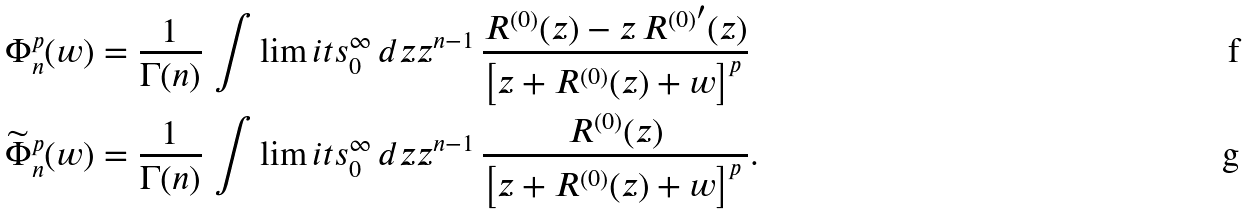<formula> <loc_0><loc_0><loc_500><loc_500>\Phi ^ { p } _ { n } ( w ) & = \frac { 1 } { \Gamma ( n ) } \, \int \lim i t s _ { 0 } ^ { \infty } \, d z z ^ { n - 1 } \, \frac { R ^ { ( 0 ) } ( z ) - z \, { R ^ { ( 0 ) } } ^ { \prime } ( z ) } { \left [ z + R ^ { ( 0 ) } ( z ) + w \right ] ^ { p } \, } \\ \widetilde { \Phi } ^ { p } _ { n } ( w ) & = \frac { 1 } { \Gamma ( n ) } \, \int \lim i t s _ { 0 } ^ { \infty } \, d z z ^ { n - 1 } \, \frac { R ^ { ( 0 ) } ( z ) } { \left [ z + R ^ { ( 0 ) } ( z ) + w \right ] ^ { p } \, } .</formula> 